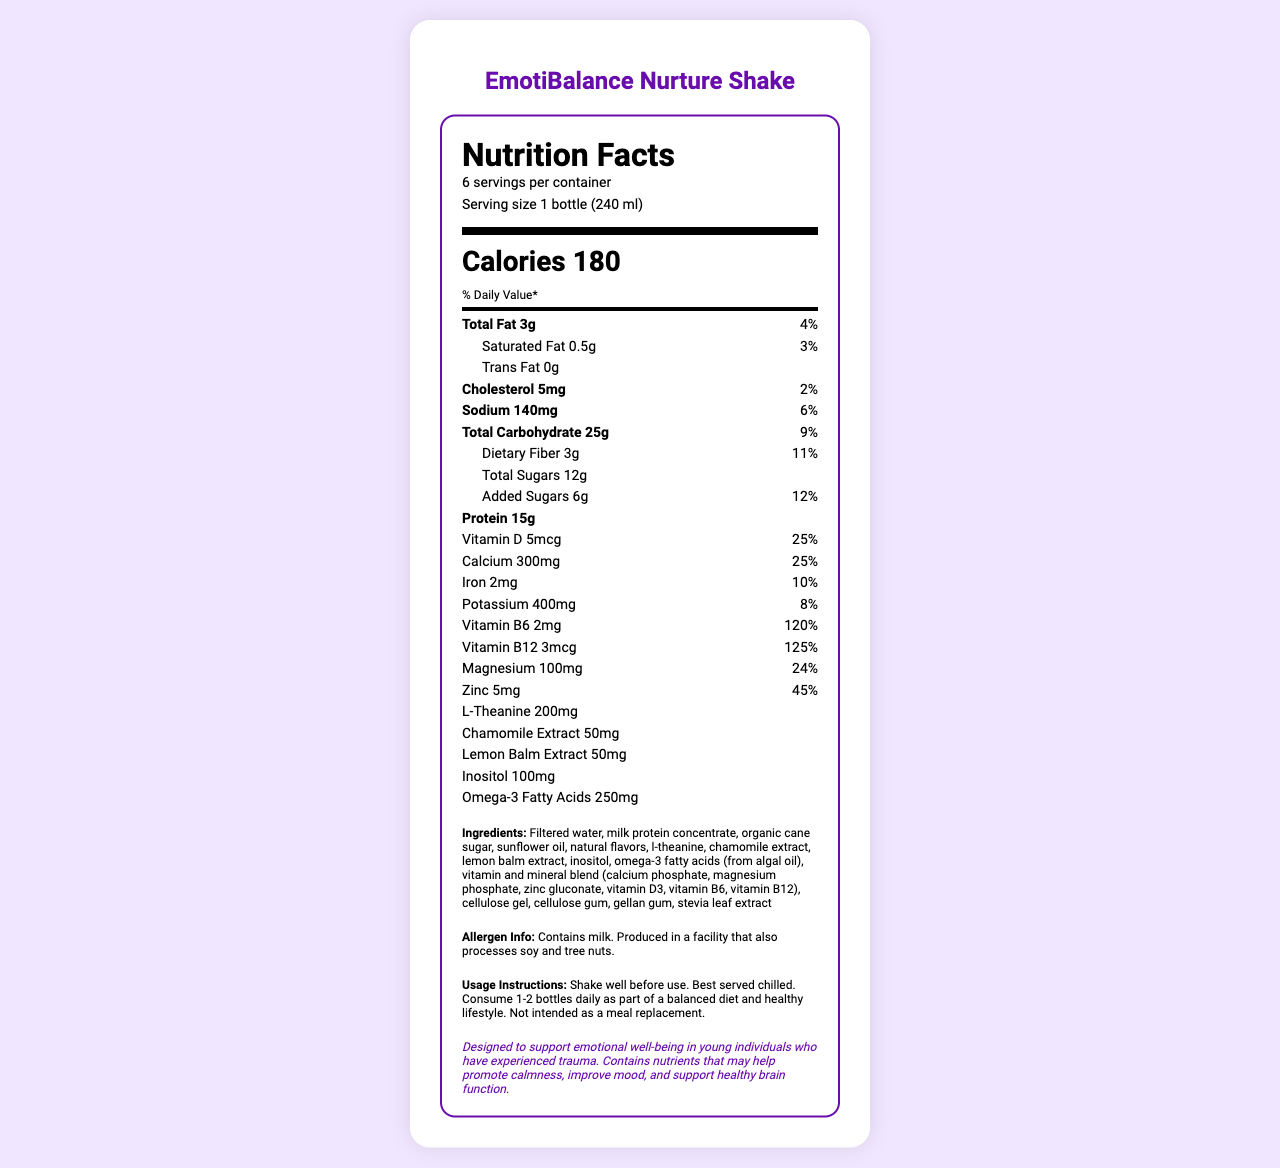what is the serving size? The document states that the serving size is 1 bottle (240 ml).
Answer: 1 bottle (240 ml) how many calories are in a serving? The document specifies that each serving has 180 calories.
Answer: 180 what is the amount of total fat per serving and its daily value percentage? The document lists the total fat as 3g with a 4% daily value.
Answer: 3g, 4% how much protein is in one serving? The document indicates that one serving contains 15g of protein.
Answer: 15g what vitamins and minerals are included in this supplement? The document lists all these vitamins and minerals with their respective amounts and daily value percentages.
Answer: Vitamin D, Calcium, Iron, Potassium, Vitamin B6, Vitamin B12, Magnesium, Zinc What is the amount of dietary fiber per serving? The document specifies that each serving contains 3g of dietary fiber.
Answer: 3g Is the product suitable for those allergic to soy or tree nuts? Yes/No The allergen information states that the product is produced in a facility that also processes soy and tree nuts.
Answer: No Which nutrient has the highest daily value percentage? The document shows that Vitamin B12 has a daily value of 125%, which is the highest among the listed nutrients.
Answer: Vitamin B12 How many servings are there per container? The document states there are 6 servings per container.
Answer: 6 Which ingredient is listed first in the ingredients section? The ingredients list starts with filtered water.
Answer: Filtered water How much inositol is in one serving? A. 50mg B. 100mg C. 150mg D. 200mg The document indicates that one serving contains 100mg of inositol.
Answer: B. 100mg Which extract is in greater amount, Chamomile Extract or Lemon Balm Extract? 1) Chamomile Extract 2) Lemon Balm Extract 3) Both are equal Both Chamomile Extract and Lemon Balm Extract are listed with 50mg each in the document.
Answer: 3) Both are equal Can this product be used as a meal replacement? The usage instructions specifically state that it is not intended as a meal replacement.
Answer: No What is the main purpose of this supplement drink? The special note states that the drink is designed to support emotional well-being in young individuals who have experienced trauma.
Answer: To support emotional well-being in young individuals who have experienced trauma. What is the total amount of potassium in one serving? The document states that there is 400mg of potassium per serving.
Answer: 400mg How much added sugar does one bottle contain? The document lists 6g of added sugars per serving.
Answer: 6g Summarize the main idea of the document. The EmotiBalance Nurture Shake is highlighted as a supportive supplement for emotional health, specifically for young individuals who have experienced trauma. The document provides detailed nutritional information, reinforcing its calming and mood-improving properties.
Answer: The document describes the nutrition facts, ingredients, and purpose of the EmotiBalance Nurture Shake, a nutritional supplement designed to support emotional well-being. It outlines the serving size, calorie count, and the amounts of various nutrients, vitamins, and minerals, including potential allergens and usage instructions. What is the amount of omega-3 fatty acids in the shake? The document lists the omega-3 fatty acids content as 250mg per serving.
Answer: 250mg Who are the intended consumers of this product? The special note mentions that the product is designed to support emotional well-being in young individuals who have experienced trauma.
Answer: Young individuals who have experienced trauma What kind of natural flavors are used in the product? The document lists "natural flavors" as an ingredient, but it does not specify what types or sources of natural flavors are included.
Answer: Not enough information 